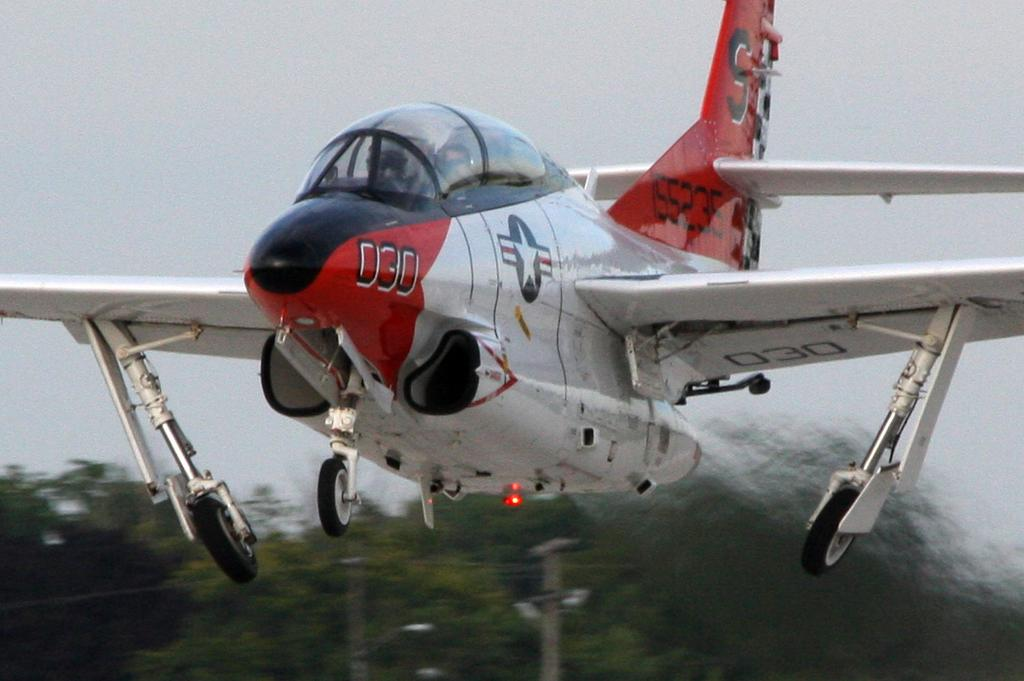<image>
Write a terse but informative summary of the picture. Military plane 030 is primarily white with red and flue on the tail and nose. 